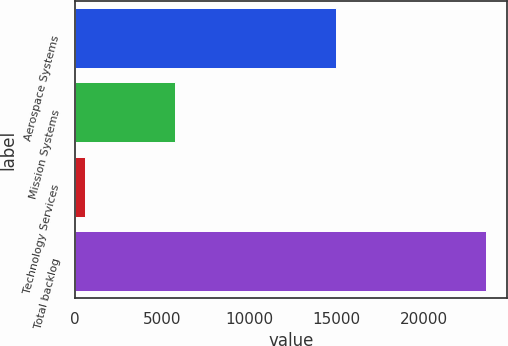Convert chart to OTSL. <chart><loc_0><loc_0><loc_500><loc_500><bar_chart><fcel>Aerospace Systems<fcel>Mission Systems<fcel>Technology Services<fcel>Total backlog<nl><fcel>14992<fcel>5732<fcel>562<fcel>23565<nl></chart> 